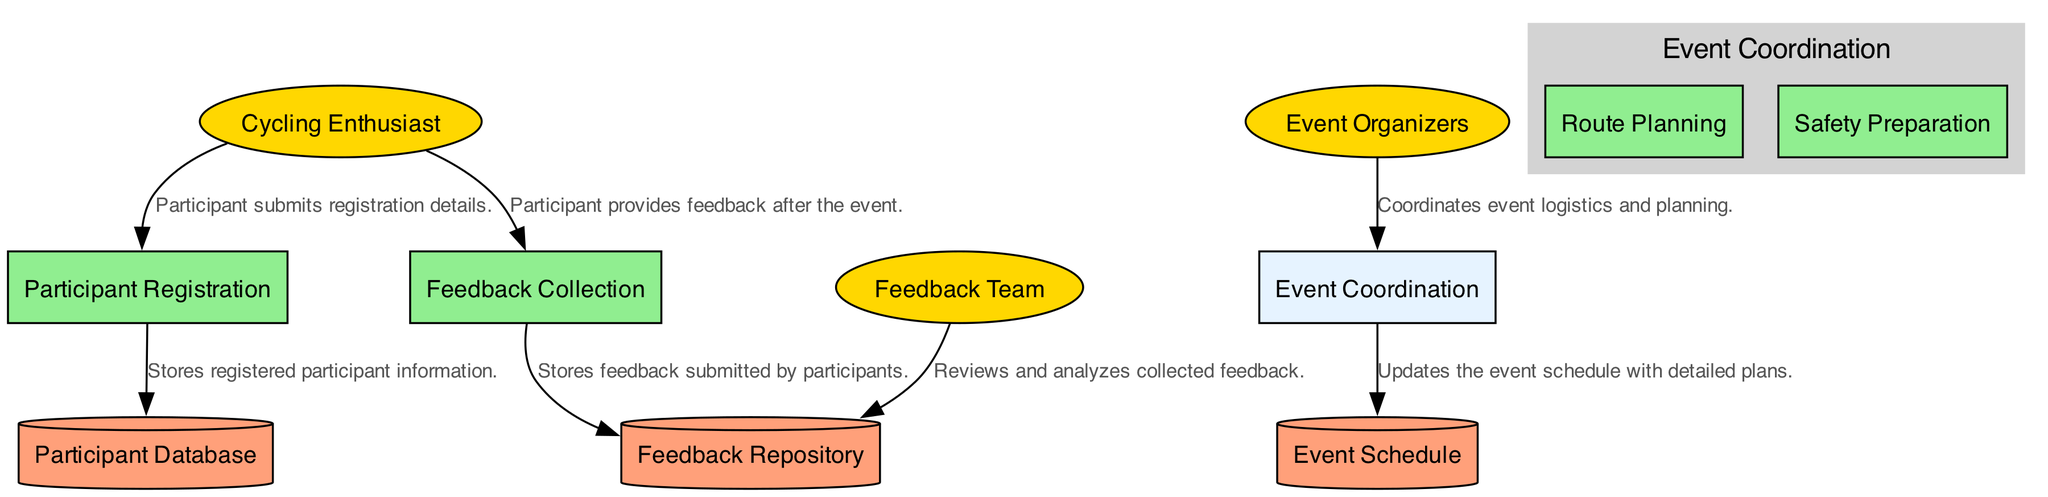What is the name of the process where participants register? The process where participants register is labeled as "Participant Registration" in the diagram.
Answer: Participant Registration How many external entities are present in the diagram? There are three external entities: "Cycling Enthusiast," "Event Organizers," and "Feedback Team." Hence, the total count is three.
Answer: 3 What does the Feedback Team do with the Feedback Repository? The Feedback Team reviews and analyzes collected feedback stored in the Feedback Repository.
Answer: Reviews and analyzes Which process involves Route Planning as a sub-process? The process that includes Route Planning as a sub-process is "Event Coordination." This is indicated where sub-processes are detailed under it.
Answer: Event Coordination What type of data is stored in the Participant Database? The Participant Database stores information about registered participants, as indicated in the description provided in the diagram.
Answer: Registered participant information What is the relationship between Cycling Enthusiasts and Feedback Collection? The Cycling Enthusiasts provide feedback after the event to the Feedback Collection process, indicating a flow of information from one to the other.
Answer: Provides feedback Which data store holds the event's detailed schedules and plans? The data store that contains the detailed schedules and plans for the events is named "Event Schedule," clearly stating its purpose.
Answer: Event Schedule What is the output of the Event Coordination process? The Event Coordination process updates the Event Schedule with detailed plans, marking this as its primary output according to the diagram flows.
Answer: Updates the event schedule Who is responsible for collecting and analyzing participant feedback? The group tasked with collecting and analyzing participant feedback is identified as the "Feedback Team" in the diagram.
Answer: Feedback Team 